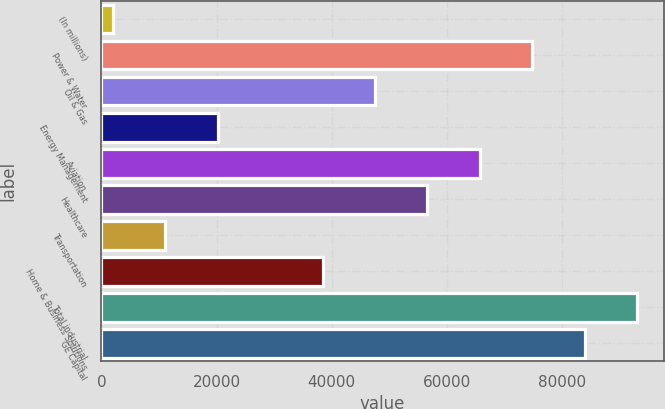<chart> <loc_0><loc_0><loc_500><loc_500><bar_chart><fcel>(In millions)<fcel>Power & Water<fcel>Oil & Gas<fcel>Energy Management<fcel>Aviation<fcel>Healthcare<fcel>Transportation<fcel>Home & Business Solutions<fcel>Total industrial<fcel>GE Capital<nl><fcel>2011<fcel>74872.6<fcel>47549.5<fcel>20226.4<fcel>65764.9<fcel>56657.2<fcel>11118.7<fcel>38441.8<fcel>93088<fcel>83980.3<nl></chart> 